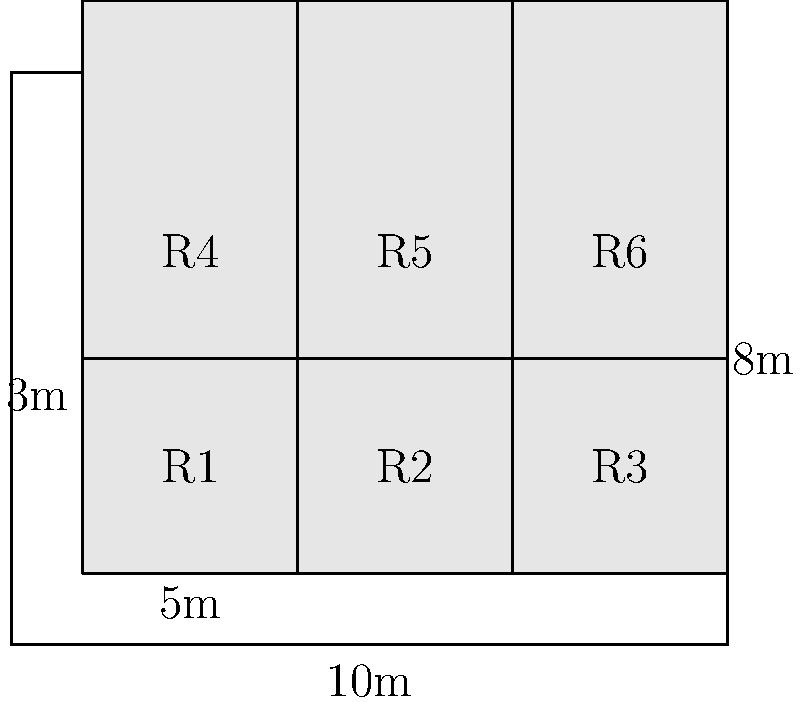A small business is optimizing its server room layout. The room measures 10m x 8m and can accommodate six server racks, each 3m wide and 5m tall, as shown in the diagram. The business wants to maximize the distance between racks for better airflow and maintenance access. What is the total area (in square meters) of unused floor space in this configuration? To solve this problem, we'll follow these steps:

1. Calculate the total area of the room:
   $A_{room} = 10m \times 8m = 80m^2$

2. Calculate the area occupied by each rack:
   $A_{rack} = 3m \times 5m = 15m^2$

3. Calculate the total area occupied by all six racks:
   $A_{total\_racks} = 6 \times 15m^2 = 90m^2$

4. However, the racks are standing vertically, so we need to calculate their footprint on the floor:
   $A_{footprint} = 3m \times 1m = 3m^2$ per rack

5. Calculate the total footprint of all six racks:
   $A_{total\_footprint} = 6 \times 3m^2 = 18m^2$

6. Calculate the unused floor space:
   $A_{unused} = A_{room} - A_{total\_footprint}$
   $A_{unused} = 80m^2 - 18m^2 = 62m^2$

Therefore, the total area of unused floor space is 62 square meters.
Answer: 62 $m^2$ 